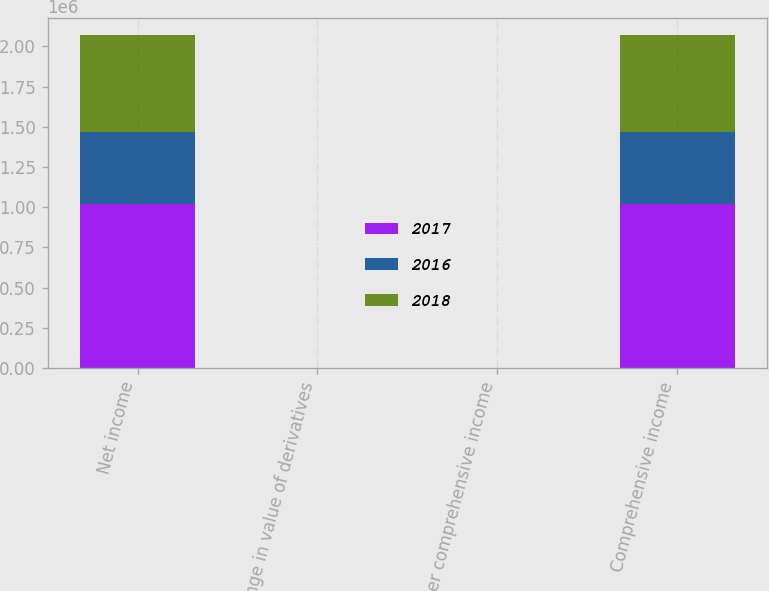<chart> <loc_0><loc_0><loc_500><loc_500><stacked_bar_chart><ecel><fcel>Net income<fcel>Change in value of derivatives<fcel>Other comprehensive income<fcel>Comprehensive income<nl><fcel>2017<fcel>1.02202e+06<fcel>100<fcel>100<fcel>1.02212e+06<nl><fcel>2016<fcel>447221<fcel>81<fcel>81<fcel>447302<nl><fcel>2018<fcel>602703<fcel>83<fcel>83<fcel>602786<nl></chart> 